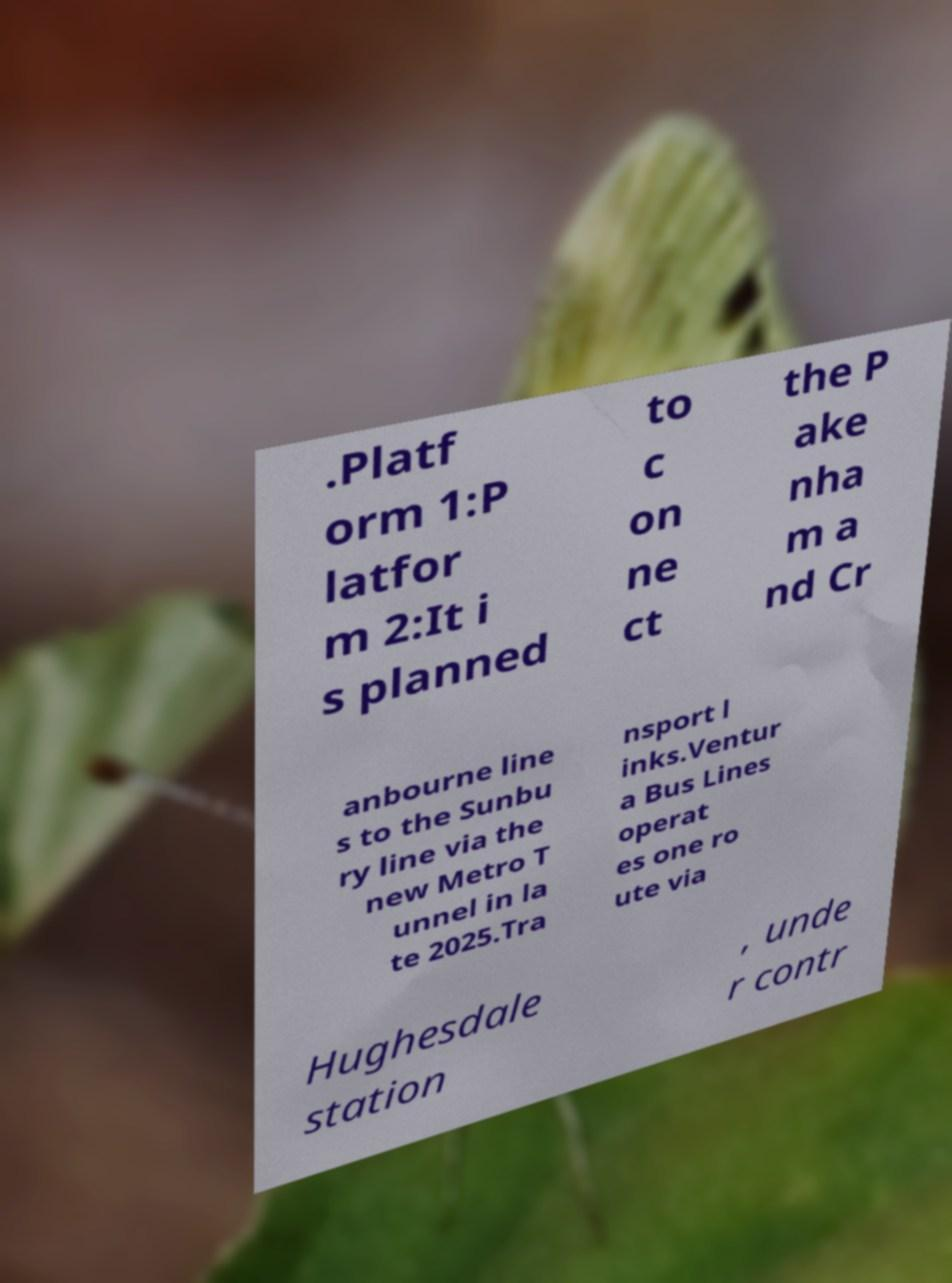For documentation purposes, I need the text within this image transcribed. Could you provide that? .Platf orm 1:P latfor m 2:It i s planned to c on ne ct the P ake nha m a nd Cr anbourne line s to the Sunbu ry line via the new Metro T unnel in la te 2025.Tra nsport l inks.Ventur a Bus Lines operat es one ro ute via Hughesdale station , unde r contr 